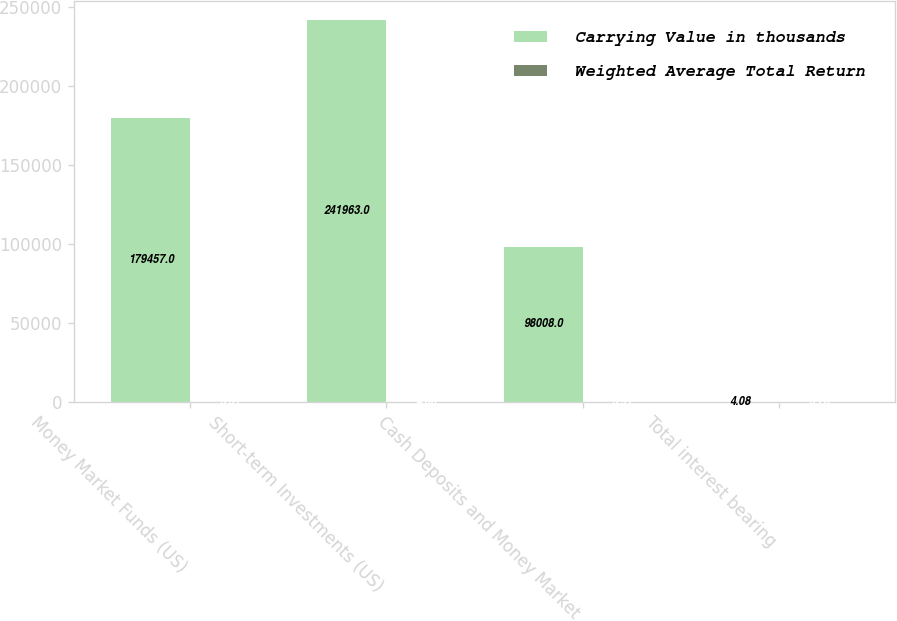Convert chart to OTSL. <chart><loc_0><loc_0><loc_500><loc_500><stacked_bar_chart><ecel><fcel>Money Market Funds (US)<fcel>Short-term Investments (US)<fcel>Cash Deposits and Money Market<fcel>Total interest bearing<nl><fcel>Carrying Value in thousands<fcel>179457<fcel>241963<fcel>98008<fcel>4.08<nl><fcel>Weighted Average Total Return<fcel>3.31<fcel>4.08<fcel>3.91<fcel>3.78<nl></chart> 